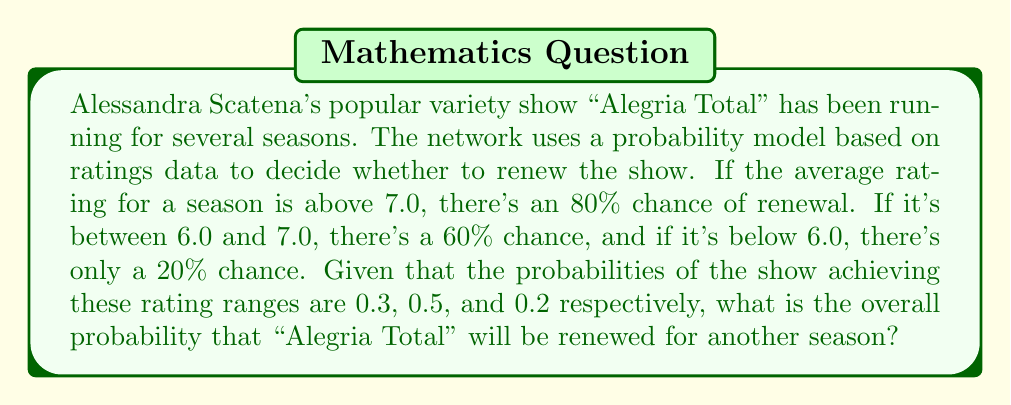Can you solve this math problem? Let's approach this step-by-step using the Law of Total Probability:

1) Define events:
   $R_1$: Rating > 7.0
   $R_2$: 6.0 ≤ Rating ≤ 7.0
   $R_3$: Rating < 6.0
   $A$: Show is renewed

2) Given probabilities:
   $P(R_1) = 0.3$, $P(R_2) = 0.5$, $P(R_3) = 0.2$
   $P(A|R_1) = 0.8$, $P(A|R_2) = 0.6$, $P(A|R_3) = 0.2$

3) Using the Law of Total Probability:
   $$P(A) = P(A|R_1)P(R_1) + P(A|R_2)P(R_2) + P(A|R_3)P(R_3)$$

4) Substituting the values:
   $$P(A) = (0.8)(0.3) + (0.6)(0.5) + (0.2)(0.2)$$

5) Calculating:
   $$P(A) = 0.24 + 0.30 + 0.04 = 0.58$$

Therefore, the overall probability that "Alegria Total" will be renewed is 0.58 or 58%.
Answer: 0.58 or 58% 